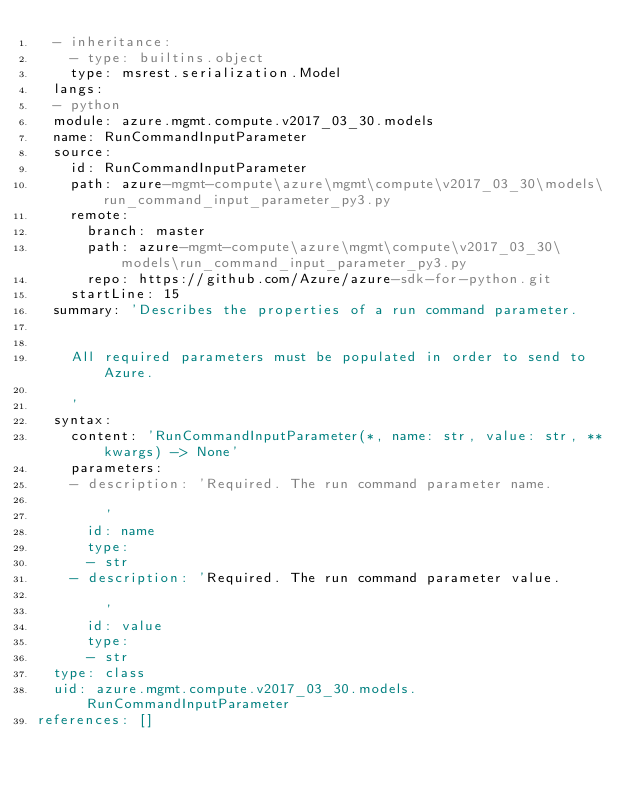Convert code to text. <code><loc_0><loc_0><loc_500><loc_500><_YAML_>  - inheritance:
    - type: builtins.object
    type: msrest.serialization.Model
  langs:
  - python
  module: azure.mgmt.compute.v2017_03_30.models
  name: RunCommandInputParameter
  source:
    id: RunCommandInputParameter
    path: azure-mgmt-compute\azure\mgmt\compute\v2017_03_30\models\run_command_input_parameter_py3.py
    remote:
      branch: master
      path: azure-mgmt-compute\azure\mgmt\compute\v2017_03_30\models\run_command_input_parameter_py3.py
      repo: https://github.com/Azure/azure-sdk-for-python.git
    startLine: 15
  summary: 'Describes the properties of a run command parameter.


    All required parameters must be populated in order to send to Azure.

    '
  syntax:
    content: 'RunCommandInputParameter(*, name: str, value: str, **kwargs) -> None'
    parameters:
    - description: 'Required. The run command parameter name.

        '
      id: name
      type:
      - str
    - description: 'Required. The run command parameter value.

        '
      id: value
      type:
      - str
  type: class
  uid: azure.mgmt.compute.v2017_03_30.models.RunCommandInputParameter
references: []
</code> 